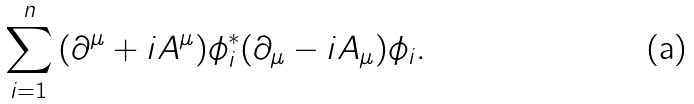Convert formula to latex. <formula><loc_0><loc_0><loc_500><loc_500>\sum _ { i = 1 } ^ { n } { ( \partial ^ { \mu } + i A ^ { \mu } ) \phi ^ { * } _ { i } ( \partial _ { \mu } - i A _ { \mu } ) \phi _ { i } } .</formula> 